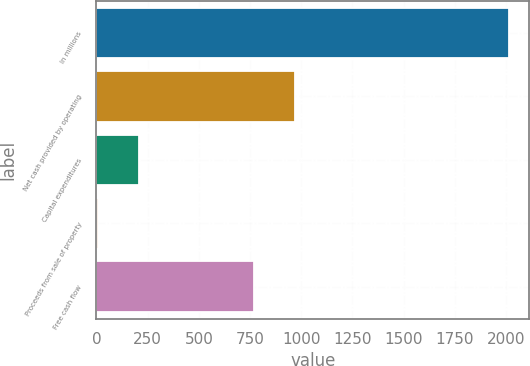Convert chart. <chart><loc_0><loc_0><loc_500><loc_500><bar_chart><fcel>In millions<fcel>Net cash provided by operating<fcel>Capital expenditures<fcel>Proceeds from sale of property<fcel>Free cash flow<nl><fcel>2013<fcel>968<fcel>206.7<fcel>6<fcel>767.3<nl></chart> 